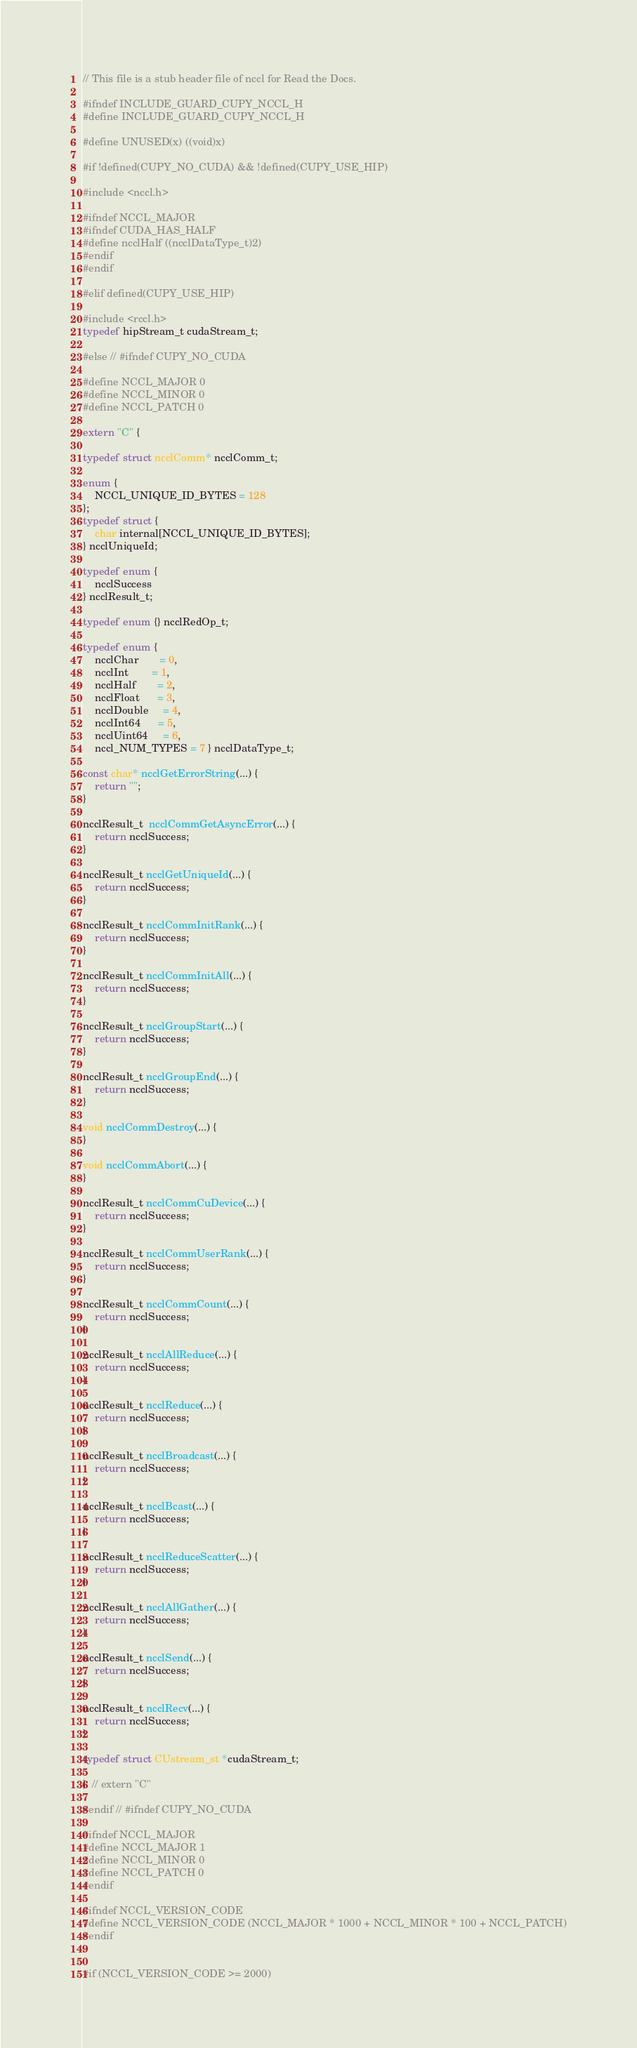<code> <loc_0><loc_0><loc_500><loc_500><_C_>// This file is a stub header file of nccl for Read the Docs.

#ifndef INCLUDE_GUARD_CUPY_NCCL_H
#define INCLUDE_GUARD_CUPY_NCCL_H

#define UNUSED(x) ((void)x)

#if !defined(CUPY_NO_CUDA) && !defined(CUPY_USE_HIP)

#include <nccl.h>

#ifndef NCCL_MAJOR
#ifndef CUDA_HAS_HALF
#define ncclHalf ((ncclDataType_t)2)
#endif
#endif

#elif defined(CUPY_USE_HIP)

#include <rccl.h>
typedef hipStream_t cudaStream_t;

#else // #ifndef CUPY_NO_CUDA

#define NCCL_MAJOR 0
#define NCCL_MINOR 0
#define NCCL_PATCH 0

extern "C" {

typedef struct ncclComm* ncclComm_t;

enum {
    NCCL_UNIQUE_ID_BYTES = 128
};
typedef struct {
    char internal[NCCL_UNIQUE_ID_BYTES];
} ncclUniqueId;

typedef enum {
    ncclSuccess
} ncclResult_t;

typedef enum {} ncclRedOp_t;

typedef enum {
    ncclChar       = 0,
    ncclInt        = 1,
    ncclHalf       = 2,
    ncclFloat      = 3,
    ncclDouble     = 4,
    ncclInt64      = 5,
    ncclUint64     = 6,
    nccl_NUM_TYPES = 7 } ncclDataType_t;

const char* ncclGetErrorString(...) {
    return "";
}

ncclResult_t  ncclCommGetAsyncError(...) {
    return ncclSuccess;
}

ncclResult_t ncclGetUniqueId(...) {
    return ncclSuccess;
}

ncclResult_t ncclCommInitRank(...) {
    return ncclSuccess;
}

ncclResult_t ncclCommInitAll(...) {
    return ncclSuccess;
}

ncclResult_t ncclGroupStart(...) {
    return ncclSuccess;
}

ncclResult_t ncclGroupEnd(...) {
    return ncclSuccess;
}

void ncclCommDestroy(...) {
}

void ncclCommAbort(...) {
}

ncclResult_t ncclCommCuDevice(...) {
    return ncclSuccess;
}

ncclResult_t ncclCommUserRank(...) {
    return ncclSuccess;
}

ncclResult_t ncclCommCount(...) {
    return ncclSuccess;
}

ncclResult_t ncclAllReduce(...) {
    return ncclSuccess;
}

ncclResult_t ncclReduce(...) {
    return ncclSuccess;
}

ncclResult_t ncclBroadcast(...) {
    return ncclSuccess;
}

ncclResult_t ncclBcast(...) {
    return ncclSuccess;
}

ncclResult_t ncclReduceScatter(...) {
    return ncclSuccess;
}

ncclResult_t ncclAllGather(...) {
    return ncclSuccess;
}

ncclResult_t ncclSend(...) {
    return ncclSuccess;
}

ncclResult_t ncclRecv(...) {
    return ncclSuccess;
}

typedef struct CUstream_st *cudaStream_t;

}  // extern "C"

#endif // #ifndef CUPY_NO_CUDA

#ifndef NCCL_MAJOR
#define NCCL_MAJOR 1
#define NCCL_MINOR 0
#define NCCL_PATCH 0
#endif

#ifndef NCCL_VERSION_CODE
#define NCCL_VERSION_CODE (NCCL_MAJOR * 1000 + NCCL_MINOR * 100 + NCCL_PATCH)
#endif


#if (NCCL_VERSION_CODE >= 2000)
</code> 